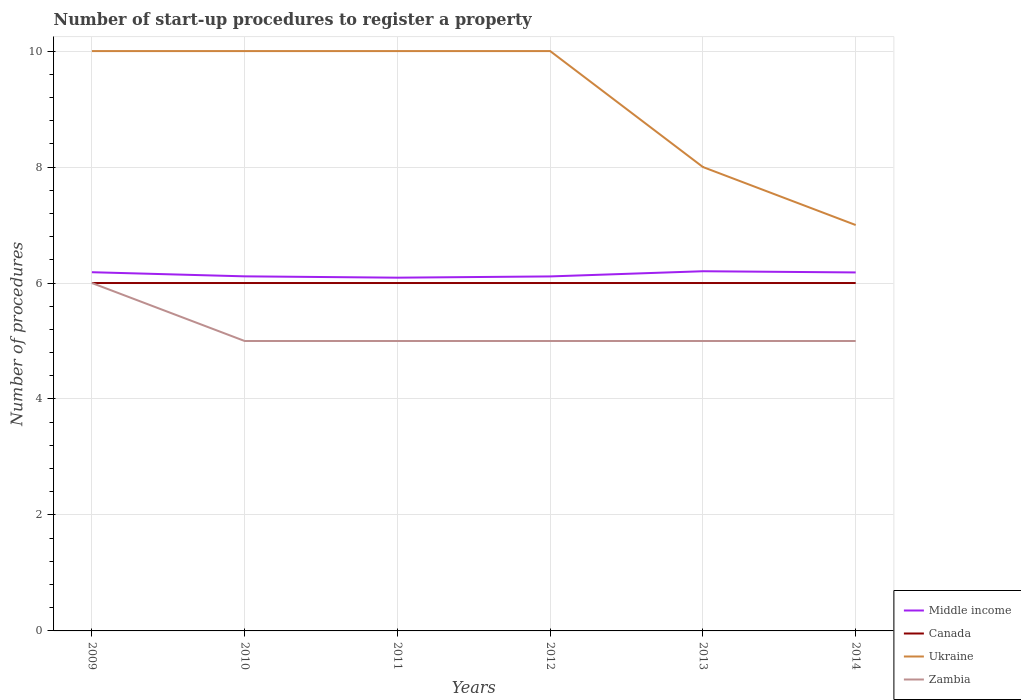How many different coloured lines are there?
Ensure brevity in your answer.  4. Does the line corresponding to Middle income intersect with the line corresponding to Canada?
Provide a succinct answer. No. Is the number of lines equal to the number of legend labels?
Offer a very short reply. Yes. Across all years, what is the maximum number of procedures required to register a property in Middle income?
Offer a very short reply. 6.09. In which year was the number of procedures required to register a property in Middle income maximum?
Provide a short and direct response. 2011. Is the number of procedures required to register a property in Ukraine strictly greater than the number of procedures required to register a property in Zambia over the years?
Give a very brief answer. No. How many lines are there?
Provide a succinct answer. 4. What is the difference between two consecutive major ticks on the Y-axis?
Make the answer very short. 2. Are the values on the major ticks of Y-axis written in scientific E-notation?
Provide a succinct answer. No. Does the graph contain grids?
Give a very brief answer. Yes. Where does the legend appear in the graph?
Keep it short and to the point. Bottom right. What is the title of the graph?
Your response must be concise. Number of start-up procedures to register a property. Does "Indonesia" appear as one of the legend labels in the graph?
Provide a short and direct response. No. What is the label or title of the Y-axis?
Provide a short and direct response. Number of procedures. What is the Number of procedures in Middle income in 2009?
Provide a succinct answer. 6.19. What is the Number of procedures in Canada in 2009?
Make the answer very short. 6. What is the Number of procedures in Ukraine in 2009?
Offer a very short reply. 10. What is the Number of procedures of Middle income in 2010?
Make the answer very short. 6.11. What is the Number of procedures in Canada in 2010?
Ensure brevity in your answer.  6. What is the Number of procedures in Zambia in 2010?
Keep it short and to the point. 5. What is the Number of procedures in Middle income in 2011?
Make the answer very short. 6.09. What is the Number of procedures of Middle income in 2012?
Ensure brevity in your answer.  6.11. What is the Number of procedures of Middle income in 2013?
Provide a short and direct response. 6.2. What is the Number of procedures of Canada in 2013?
Ensure brevity in your answer.  6. What is the Number of procedures of Ukraine in 2013?
Provide a succinct answer. 8. What is the Number of procedures in Zambia in 2013?
Keep it short and to the point. 5. What is the Number of procedures in Middle income in 2014?
Your answer should be compact. 6.18. What is the Number of procedures of Canada in 2014?
Make the answer very short. 6. What is the Number of procedures of Ukraine in 2014?
Your answer should be very brief. 7. What is the Number of procedures in Zambia in 2014?
Ensure brevity in your answer.  5. Across all years, what is the maximum Number of procedures of Middle income?
Your answer should be very brief. 6.2. Across all years, what is the maximum Number of procedures of Ukraine?
Offer a very short reply. 10. Across all years, what is the maximum Number of procedures in Zambia?
Keep it short and to the point. 6. Across all years, what is the minimum Number of procedures of Middle income?
Your response must be concise. 6.09. Across all years, what is the minimum Number of procedures of Zambia?
Your answer should be very brief. 5. What is the total Number of procedures in Middle income in the graph?
Your answer should be compact. 36.89. What is the total Number of procedures in Canada in the graph?
Offer a terse response. 36. What is the total Number of procedures of Zambia in the graph?
Provide a succinct answer. 31. What is the difference between the Number of procedures of Middle income in 2009 and that in 2010?
Your answer should be compact. 0.07. What is the difference between the Number of procedures in Middle income in 2009 and that in 2011?
Offer a very short reply. 0.09. What is the difference between the Number of procedures of Canada in 2009 and that in 2011?
Give a very brief answer. 0. What is the difference between the Number of procedures in Zambia in 2009 and that in 2011?
Your answer should be very brief. 1. What is the difference between the Number of procedures in Middle income in 2009 and that in 2012?
Offer a very short reply. 0.07. What is the difference between the Number of procedures of Ukraine in 2009 and that in 2012?
Give a very brief answer. 0. What is the difference between the Number of procedures of Middle income in 2009 and that in 2013?
Make the answer very short. -0.02. What is the difference between the Number of procedures of Ukraine in 2009 and that in 2013?
Make the answer very short. 2. What is the difference between the Number of procedures of Middle income in 2009 and that in 2014?
Your response must be concise. 0. What is the difference between the Number of procedures of Zambia in 2009 and that in 2014?
Your answer should be very brief. 1. What is the difference between the Number of procedures of Middle income in 2010 and that in 2011?
Your answer should be very brief. 0.02. What is the difference between the Number of procedures of Ukraine in 2010 and that in 2011?
Make the answer very short. 0. What is the difference between the Number of procedures of Zambia in 2010 and that in 2011?
Give a very brief answer. 0. What is the difference between the Number of procedures in Middle income in 2010 and that in 2012?
Make the answer very short. 0. What is the difference between the Number of procedures in Middle income in 2010 and that in 2013?
Ensure brevity in your answer.  -0.09. What is the difference between the Number of procedures in Zambia in 2010 and that in 2013?
Give a very brief answer. 0. What is the difference between the Number of procedures in Middle income in 2010 and that in 2014?
Provide a succinct answer. -0.07. What is the difference between the Number of procedures in Canada in 2010 and that in 2014?
Your answer should be compact. 0. What is the difference between the Number of procedures of Middle income in 2011 and that in 2012?
Your answer should be compact. -0.02. What is the difference between the Number of procedures in Canada in 2011 and that in 2012?
Your answer should be compact. 0. What is the difference between the Number of procedures of Middle income in 2011 and that in 2013?
Give a very brief answer. -0.11. What is the difference between the Number of procedures of Canada in 2011 and that in 2013?
Provide a succinct answer. 0. What is the difference between the Number of procedures in Zambia in 2011 and that in 2013?
Your response must be concise. 0. What is the difference between the Number of procedures in Middle income in 2011 and that in 2014?
Make the answer very short. -0.09. What is the difference between the Number of procedures in Canada in 2011 and that in 2014?
Give a very brief answer. 0. What is the difference between the Number of procedures in Zambia in 2011 and that in 2014?
Your answer should be very brief. 0. What is the difference between the Number of procedures of Middle income in 2012 and that in 2013?
Provide a succinct answer. -0.09. What is the difference between the Number of procedures of Middle income in 2012 and that in 2014?
Ensure brevity in your answer.  -0.07. What is the difference between the Number of procedures in Canada in 2012 and that in 2014?
Make the answer very short. 0. What is the difference between the Number of procedures of Middle income in 2013 and that in 2014?
Provide a short and direct response. 0.02. What is the difference between the Number of procedures in Canada in 2013 and that in 2014?
Your response must be concise. 0. What is the difference between the Number of procedures in Middle income in 2009 and the Number of procedures in Canada in 2010?
Provide a succinct answer. 0.19. What is the difference between the Number of procedures of Middle income in 2009 and the Number of procedures of Ukraine in 2010?
Provide a succinct answer. -3.81. What is the difference between the Number of procedures in Middle income in 2009 and the Number of procedures in Zambia in 2010?
Provide a succinct answer. 1.19. What is the difference between the Number of procedures of Canada in 2009 and the Number of procedures of Zambia in 2010?
Make the answer very short. 1. What is the difference between the Number of procedures in Ukraine in 2009 and the Number of procedures in Zambia in 2010?
Your answer should be compact. 5. What is the difference between the Number of procedures in Middle income in 2009 and the Number of procedures in Canada in 2011?
Your response must be concise. 0.19. What is the difference between the Number of procedures in Middle income in 2009 and the Number of procedures in Ukraine in 2011?
Give a very brief answer. -3.81. What is the difference between the Number of procedures of Middle income in 2009 and the Number of procedures of Zambia in 2011?
Provide a succinct answer. 1.19. What is the difference between the Number of procedures in Canada in 2009 and the Number of procedures in Ukraine in 2011?
Your answer should be very brief. -4. What is the difference between the Number of procedures in Canada in 2009 and the Number of procedures in Zambia in 2011?
Ensure brevity in your answer.  1. What is the difference between the Number of procedures of Ukraine in 2009 and the Number of procedures of Zambia in 2011?
Your response must be concise. 5. What is the difference between the Number of procedures of Middle income in 2009 and the Number of procedures of Canada in 2012?
Ensure brevity in your answer.  0.19. What is the difference between the Number of procedures in Middle income in 2009 and the Number of procedures in Ukraine in 2012?
Provide a succinct answer. -3.81. What is the difference between the Number of procedures of Middle income in 2009 and the Number of procedures of Zambia in 2012?
Provide a succinct answer. 1.19. What is the difference between the Number of procedures in Canada in 2009 and the Number of procedures in Ukraine in 2012?
Give a very brief answer. -4. What is the difference between the Number of procedures in Canada in 2009 and the Number of procedures in Zambia in 2012?
Offer a very short reply. 1. What is the difference between the Number of procedures of Ukraine in 2009 and the Number of procedures of Zambia in 2012?
Provide a short and direct response. 5. What is the difference between the Number of procedures of Middle income in 2009 and the Number of procedures of Canada in 2013?
Provide a succinct answer. 0.19. What is the difference between the Number of procedures of Middle income in 2009 and the Number of procedures of Ukraine in 2013?
Offer a terse response. -1.81. What is the difference between the Number of procedures of Middle income in 2009 and the Number of procedures of Zambia in 2013?
Your answer should be very brief. 1.19. What is the difference between the Number of procedures in Canada in 2009 and the Number of procedures in Zambia in 2013?
Provide a succinct answer. 1. What is the difference between the Number of procedures in Ukraine in 2009 and the Number of procedures in Zambia in 2013?
Your answer should be compact. 5. What is the difference between the Number of procedures in Middle income in 2009 and the Number of procedures in Canada in 2014?
Your answer should be very brief. 0.19. What is the difference between the Number of procedures of Middle income in 2009 and the Number of procedures of Ukraine in 2014?
Your response must be concise. -0.81. What is the difference between the Number of procedures of Middle income in 2009 and the Number of procedures of Zambia in 2014?
Provide a succinct answer. 1.19. What is the difference between the Number of procedures in Canada in 2009 and the Number of procedures in Ukraine in 2014?
Your response must be concise. -1. What is the difference between the Number of procedures of Canada in 2009 and the Number of procedures of Zambia in 2014?
Provide a short and direct response. 1. What is the difference between the Number of procedures in Ukraine in 2009 and the Number of procedures in Zambia in 2014?
Your answer should be compact. 5. What is the difference between the Number of procedures in Middle income in 2010 and the Number of procedures in Canada in 2011?
Provide a succinct answer. 0.11. What is the difference between the Number of procedures in Middle income in 2010 and the Number of procedures in Ukraine in 2011?
Provide a short and direct response. -3.89. What is the difference between the Number of procedures in Middle income in 2010 and the Number of procedures in Zambia in 2011?
Give a very brief answer. 1.11. What is the difference between the Number of procedures of Canada in 2010 and the Number of procedures of Ukraine in 2011?
Your answer should be very brief. -4. What is the difference between the Number of procedures in Canada in 2010 and the Number of procedures in Zambia in 2011?
Ensure brevity in your answer.  1. What is the difference between the Number of procedures of Middle income in 2010 and the Number of procedures of Canada in 2012?
Your answer should be very brief. 0.11. What is the difference between the Number of procedures of Middle income in 2010 and the Number of procedures of Ukraine in 2012?
Your answer should be compact. -3.89. What is the difference between the Number of procedures in Middle income in 2010 and the Number of procedures in Zambia in 2012?
Provide a succinct answer. 1.11. What is the difference between the Number of procedures of Ukraine in 2010 and the Number of procedures of Zambia in 2012?
Your response must be concise. 5. What is the difference between the Number of procedures of Middle income in 2010 and the Number of procedures of Canada in 2013?
Ensure brevity in your answer.  0.11. What is the difference between the Number of procedures of Middle income in 2010 and the Number of procedures of Ukraine in 2013?
Offer a terse response. -1.89. What is the difference between the Number of procedures in Middle income in 2010 and the Number of procedures in Zambia in 2013?
Offer a very short reply. 1.11. What is the difference between the Number of procedures in Canada in 2010 and the Number of procedures in Ukraine in 2013?
Make the answer very short. -2. What is the difference between the Number of procedures of Ukraine in 2010 and the Number of procedures of Zambia in 2013?
Your answer should be compact. 5. What is the difference between the Number of procedures in Middle income in 2010 and the Number of procedures in Canada in 2014?
Make the answer very short. 0.11. What is the difference between the Number of procedures of Middle income in 2010 and the Number of procedures of Ukraine in 2014?
Provide a succinct answer. -0.89. What is the difference between the Number of procedures of Middle income in 2010 and the Number of procedures of Zambia in 2014?
Give a very brief answer. 1.11. What is the difference between the Number of procedures in Canada in 2010 and the Number of procedures in Zambia in 2014?
Give a very brief answer. 1. What is the difference between the Number of procedures in Ukraine in 2010 and the Number of procedures in Zambia in 2014?
Make the answer very short. 5. What is the difference between the Number of procedures of Middle income in 2011 and the Number of procedures of Canada in 2012?
Ensure brevity in your answer.  0.09. What is the difference between the Number of procedures of Middle income in 2011 and the Number of procedures of Ukraine in 2012?
Your response must be concise. -3.91. What is the difference between the Number of procedures of Middle income in 2011 and the Number of procedures of Zambia in 2012?
Your response must be concise. 1.09. What is the difference between the Number of procedures in Canada in 2011 and the Number of procedures in Zambia in 2012?
Offer a terse response. 1. What is the difference between the Number of procedures in Ukraine in 2011 and the Number of procedures in Zambia in 2012?
Ensure brevity in your answer.  5. What is the difference between the Number of procedures in Middle income in 2011 and the Number of procedures in Canada in 2013?
Make the answer very short. 0.09. What is the difference between the Number of procedures in Middle income in 2011 and the Number of procedures in Ukraine in 2013?
Ensure brevity in your answer.  -1.91. What is the difference between the Number of procedures in Middle income in 2011 and the Number of procedures in Zambia in 2013?
Provide a succinct answer. 1.09. What is the difference between the Number of procedures in Middle income in 2011 and the Number of procedures in Canada in 2014?
Ensure brevity in your answer.  0.09. What is the difference between the Number of procedures of Middle income in 2011 and the Number of procedures of Ukraine in 2014?
Your answer should be very brief. -0.91. What is the difference between the Number of procedures in Middle income in 2011 and the Number of procedures in Zambia in 2014?
Give a very brief answer. 1.09. What is the difference between the Number of procedures in Canada in 2011 and the Number of procedures in Ukraine in 2014?
Your response must be concise. -1. What is the difference between the Number of procedures of Canada in 2011 and the Number of procedures of Zambia in 2014?
Your response must be concise. 1. What is the difference between the Number of procedures of Middle income in 2012 and the Number of procedures of Canada in 2013?
Offer a very short reply. 0.11. What is the difference between the Number of procedures of Middle income in 2012 and the Number of procedures of Ukraine in 2013?
Offer a very short reply. -1.89. What is the difference between the Number of procedures in Middle income in 2012 and the Number of procedures in Zambia in 2013?
Your answer should be compact. 1.11. What is the difference between the Number of procedures of Canada in 2012 and the Number of procedures of Zambia in 2013?
Make the answer very short. 1. What is the difference between the Number of procedures of Ukraine in 2012 and the Number of procedures of Zambia in 2013?
Make the answer very short. 5. What is the difference between the Number of procedures in Middle income in 2012 and the Number of procedures in Canada in 2014?
Keep it short and to the point. 0.11. What is the difference between the Number of procedures of Middle income in 2012 and the Number of procedures of Ukraine in 2014?
Your answer should be compact. -0.89. What is the difference between the Number of procedures of Middle income in 2012 and the Number of procedures of Zambia in 2014?
Your answer should be compact. 1.11. What is the difference between the Number of procedures of Ukraine in 2012 and the Number of procedures of Zambia in 2014?
Ensure brevity in your answer.  5. What is the difference between the Number of procedures in Middle income in 2013 and the Number of procedures in Canada in 2014?
Give a very brief answer. 0.2. What is the difference between the Number of procedures of Middle income in 2013 and the Number of procedures of Ukraine in 2014?
Your response must be concise. -0.8. What is the difference between the Number of procedures in Middle income in 2013 and the Number of procedures in Zambia in 2014?
Keep it short and to the point. 1.2. What is the difference between the Number of procedures of Canada in 2013 and the Number of procedures of Ukraine in 2014?
Keep it short and to the point. -1. What is the difference between the Number of procedures in Canada in 2013 and the Number of procedures in Zambia in 2014?
Your answer should be very brief. 1. What is the difference between the Number of procedures of Ukraine in 2013 and the Number of procedures of Zambia in 2014?
Provide a short and direct response. 3. What is the average Number of procedures in Middle income per year?
Give a very brief answer. 6.15. What is the average Number of procedures in Ukraine per year?
Your answer should be compact. 9.17. What is the average Number of procedures of Zambia per year?
Offer a very short reply. 5.17. In the year 2009, what is the difference between the Number of procedures of Middle income and Number of procedures of Canada?
Ensure brevity in your answer.  0.19. In the year 2009, what is the difference between the Number of procedures in Middle income and Number of procedures in Ukraine?
Offer a terse response. -3.81. In the year 2009, what is the difference between the Number of procedures of Middle income and Number of procedures of Zambia?
Keep it short and to the point. 0.19. In the year 2009, what is the difference between the Number of procedures of Canada and Number of procedures of Ukraine?
Your answer should be very brief. -4. In the year 2009, what is the difference between the Number of procedures in Ukraine and Number of procedures in Zambia?
Provide a short and direct response. 4. In the year 2010, what is the difference between the Number of procedures in Middle income and Number of procedures in Canada?
Your answer should be compact. 0.11. In the year 2010, what is the difference between the Number of procedures of Middle income and Number of procedures of Ukraine?
Your answer should be compact. -3.89. In the year 2010, what is the difference between the Number of procedures of Middle income and Number of procedures of Zambia?
Your response must be concise. 1.11. In the year 2010, what is the difference between the Number of procedures in Canada and Number of procedures in Ukraine?
Your answer should be very brief. -4. In the year 2011, what is the difference between the Number of procedures of Middle income and Number of procedures of Canada?
Your answer should be very brief. 0.09. In the year 2011, what is the difference between the Number of procedures of Middle income and Number of procedures of Ukraine?
Provide a succinct answer. -3.91. In the year 2011, what is the difference between the Number of procedures of Middle income and Number of procedures of Zambia?
Offer a terse response. 1.09. In the year 2011, what is the difference between the Number of procedures in Canada and Number of procedures in Ukraine?
Your response must be concise. -4. In the year 2012, what is the difference between the Number of procedures in Middle income and Number of procedures in Canada?
Provide a succinct answer. 0.11. In the year 2012, what is the difference between the Number of procedures of Middle income and Number of procedures of Ukraine?
Provide a short and direct response. -3.89. In the year 2012, what is the difference between the Number of procedures of Middle income and Number of procedures of Zambia?
Your answer should be compact. 1.11. In the year 2012, what is the difference between the Number of procedures in Canada and Number of procedures in Zambia?
Your answer should be compact. 1. In the year 2013, what is the difference between the Number of procedures in Middle income and Number of procedures in Canada?
Provide a succinct answer. 0.2. In the year 2013, what is the difference between the Number of procedures of Middle income and Number of procedures of Ukraine?
Give a very brief answer. -1.8. In the year 2013, what is the difference between the Number of procedures in Middle income and Number of procedures in Zambia?
Your answer should be compact. 1.2. In the year 2013, what is the difference between the Number of procedures of Ukraine and Number of procedures of Zambia?
Provide a succinct answer. 3. In the year 2014, what is the difference between the Number of procedures of Middle income and Number of procedures of Canada?
Your response must be concise. 0.18. In the year 2014, what is the difference between the Number of procedures of Middle income and Number of procedures of Ukraine?
Offer a terse response. -0.82. In the year 2014, what is the difference between the Number of procedures in Middle income and Number of procedures in Zambia?
Keep it short and to the point. 1.18. What is the ratio of the Number of procedures of Middle income in 2009 to that in 2010?
Provide a succinct answer. 1.01. What is the ratio of the Number of procedures in Zambia in 2009 to that in 2010?
Provide a succinct answer. 1.2. What is the ratio of the Number of procedures in Middle income in 2009 to that in 2011?
Your answer should be compact. 1.02. What is the ratio of the Number of procedures of Canada in 2009 to that in 2011?
Offer a very short reply. 1. What is the ratio of the Number of procedures in Zambia in 2009 to that in 2011?
Offer a very short reply. 1.2. What is the ratio of the Number of procedures in Middle income in 2009 to that in 2012?
Offer a very short reply. 1.01. What is the ratio of the Number of procedures in Middle income in 2009 to that in 2013?
Offer a very short reply. 1. What is the ratio of the Number of procedures in Ukraine in 2009 to that in 2013?
Your answer should be very brief. 1.25. What is the ratio of the Number of procedures in Canada in 2009 to that in 2014?
Offer a very short reply. 1. What is the ratio of the Number of procedures in Ukraine in 2009 to that in 2014?
Offer a very short reply. 1.43. What is the ratio of the Number of procedures in Zambia in 2009 to that in 2014?
Give a very brief answer. 1.2. What is the ratio of the Number of procedures in Middle income in 2010 to that in 2012?
Offer a very short reply. 1. What is the ratio of the Number of procedures of Zambia in 2010 to that in 2012?
Give a very brief answer. 1. What is the ratio of the Number of procedures of Middle income in 2010 to that in 2013?
Keep it short and to the point. 0.99. What is the ratio of the Number of procedures of Middle income in 2010 to that in 2014?
Offer a very short reply. 0.99. What is the ratio of the Number of procedures of Ukraine in 2010 to that in 2014?
Give a very brief answer. 1.43. What is the ratio of the Number of procedures of Zambia in 2010 to that in 2014?
Provide a succinct answer. 1. What is the ratio of the Number of procedures in Middle income in 2011 to that in 2012?
Provide a short and direct response. 1. What is the ratio of the Number of procedures in Middle income in 2011 to that in 2013?
Offer a terse response. 0.98. What is the ratio of the Number of procedures of Middle income in 2011 to that in 2014?
Your answer should be compact. 0.99. What is the ratio of the Number of procedures in Ukraine in 2011 to that in 2014?
Offer a very short reply. 1.43. What is the ratio of the Number of procedures in Middle income in 2012 to that in 2013?
Keep it short and to the point. 0.99. What is the ratio of the Number of procedures in Middle income in 2012 to that in 2014?
Your answer should be compact. 0.99. What is the ratio of the Number of procedures in Ukraine in 2012 to that in 2014?
Your answer should be compact. 1.43. What is the ratio of the Number of procedures of Zambia in 2012 to that in 2014?
Offer a terse response. 1. What is the ratio of the Number of procedures of Canada in 2013 to that in 2014?
Provide a succinct answer. 1. What is the ratio of the Number of procedures in Zambia in 2013 to that in 2014?
Offer a terse response. 1. What is the difference between the highest and the second highest Number of procedures in Middle income?
Offer a very short reply. 0.02. What is the difference between the highest and the second highest Number of procedures of Canada?
Your answer should be very brief. 0. What is the difference between the highest and the second highest Number of procedures in Ukraine?
Offer a terse response. 0. What is the difference between the highest and the second highest Number of procedures of Zambia?
Your answer should be compact. 1. What is the difference between the highest and the lowest Number of procedures in Middle income?
Your response must be concise. 0.11. What is the difference between the highest and the lowest Number of procedures of Zambia?
Provide a short and direct response. 1. 